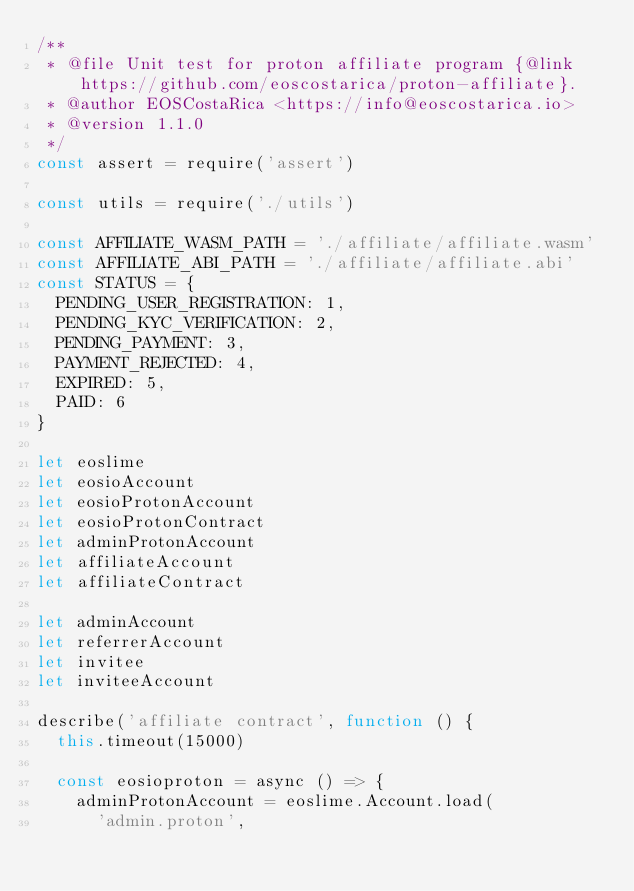<code> <loc_0><loc_0><loc_500><loc_500><_JavaScript_>/**
 * @file Unit test for proton affiliate program {@link https://github.com/eoscostarica/proton-affiliate}.
 * @author EOSCostaRica <https://info@eoscostarica.io>
 * @version 1.1.0
 */
const assert = require('assert')

const utils = require('./utils')

const AFFILIATE_WASM_PATH = './affiliate/affiliate.wasm'
const AFFILIATE_ABI_PATH = './affiliate/affiliate.abi'
const STATUS = {
  PENDING_USER_REGISTRATION: 1,
  PENDING_KYC_VERIFICATION: 2,
  PENDING_PAYMENT: 3,
  PAYMENT_REJECTED: 4,
  EXPIRED: 5,
  PAID: 6
}

let eoslime
let eosioAccount
let eosioProtonAccount
let eosioProtonContract
let adminProtonAccount
let affiliateAccount
let affiliateContract

let adminAccount
let referrerAccount
let invitee
let inviteeAccount

describe('affiliate contract', function () {
  this.timeout(15000)

  const eosioproton = async () => {
    adminProtonAccount = eoslime.Account.load(
      'admin.proton',</code> 